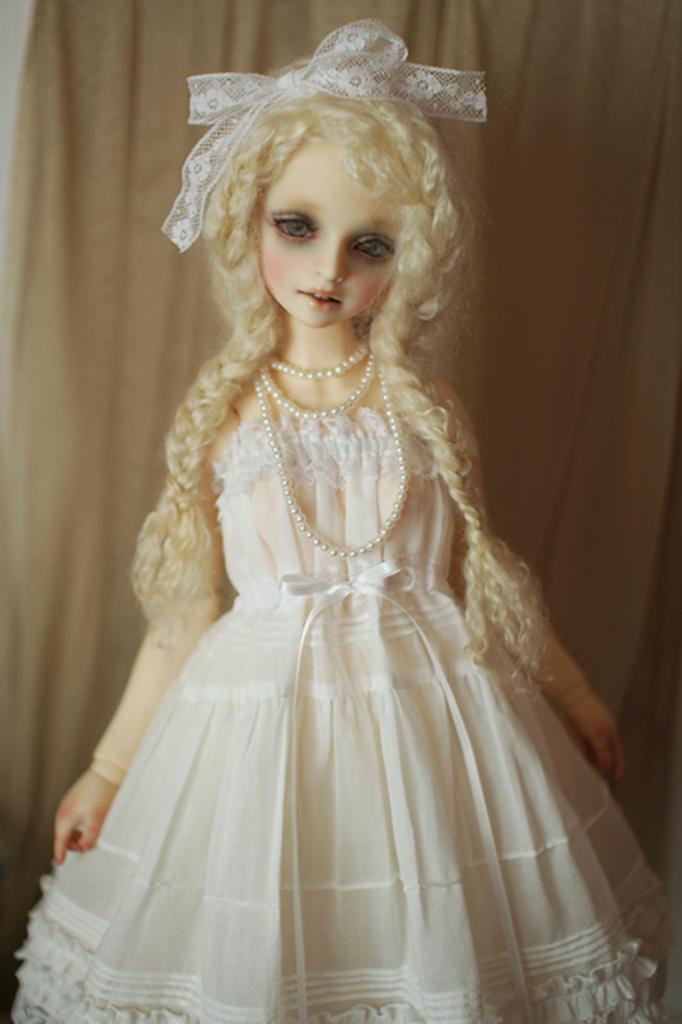What is the main subject of the image? There is a doll in the image. What is the doll wearing? The doll is wearing a white dress and a necklace. What can be seen in the background of the image? There is a curtain in the background of the image. What type of feather can be seen on the doll's head in the image? There is no feather present on the doll's head in the image. Can you describe the yard where the doll is located? The image does not show a yard, only the doll and the curtain in the background. 